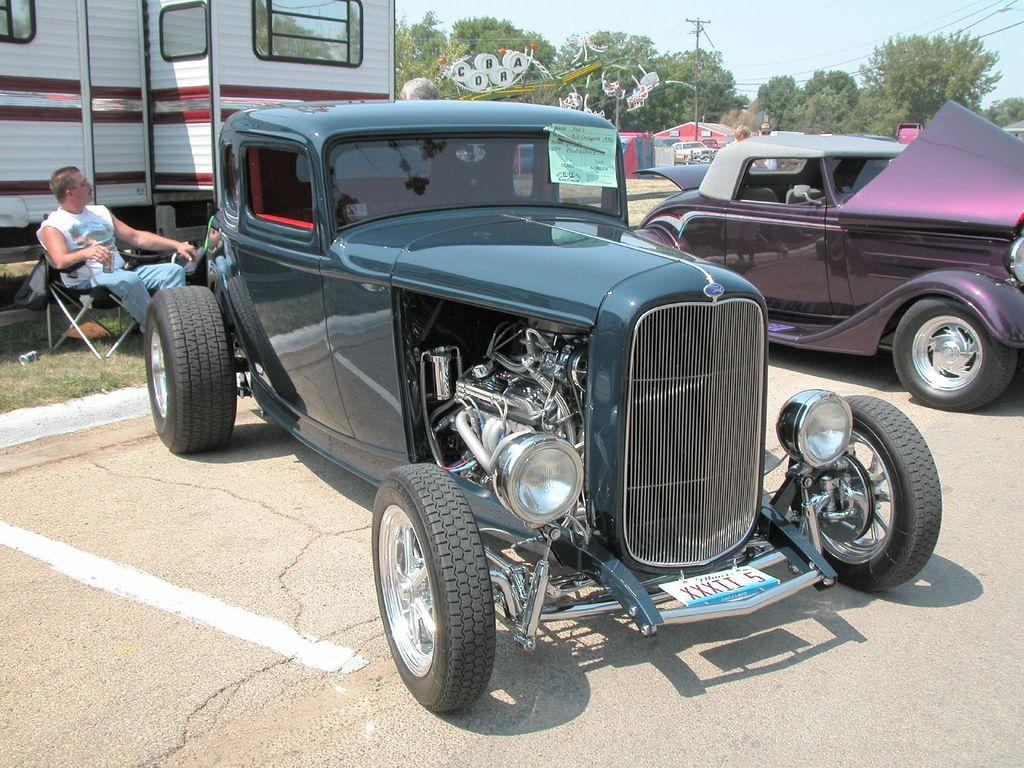What types of objects are present in the image that can transport people or goods? There are vehicles in the image. Can you describe the person in the image? There is a person sitting on a chair in the image. What type of natural elements can be seen in the image? There are trees in the image. What are the tall, thin structures in the image? There are poles in the image. What is visible in the background of the image? The sky is visible in the image. What type of brass instrument is being played by the person sitting on the chair in the image? There is no brass instrument present in the image; the person is simply sitting on a chair. How does the person sitting on the chair in the image express their disgust towards the vehicles? There is no indication of the person expressing any emotion, let alone disgust, towards the vehicles in the image. 